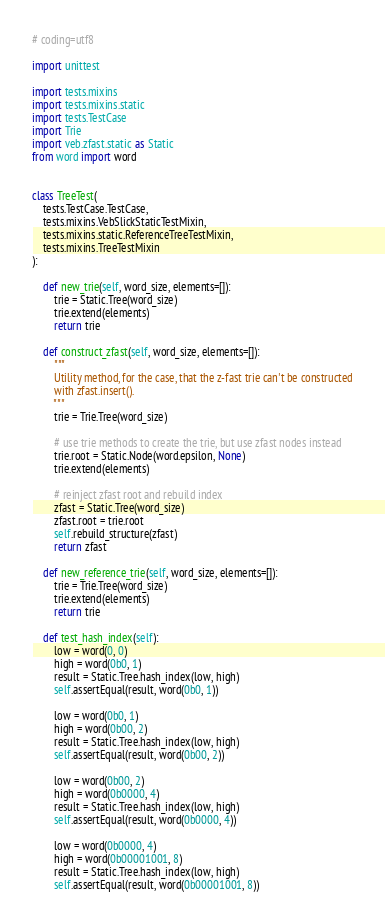<code> <loc_0><loc_0><loc_500><loc_500><_Python_># coding=utf8

import unittest

import tests.mixins
import tests.mixins.static
import tests.TestCase
import Trie
import veb.zfast.static as Static
from word import word


class TreeTest(
    tests.TestCase.TestCase,
    tests.mixins.VebSlickStaticTestMixin,
    tests.mixins.static.ReferenceTreeTestMixin,
    tests.mixins.TreeTestMixin
):

    def new_trie(self, word_size, elements=[]):
        trie = Static.Tree(word_size)
        trie.extend(elements)
        return trie

    def construct_zfast(self, word_size, elements=[]):
        """
        Utility method, for the case, that the z-fast trie can't be constructed
        with zfast.insert().
        """
        trie = Trie.Tree(word_size)

        # use trie methods to create the trie, but use zfast nodes instead
        trie.root = Static.Node(word.epsilon, None)
        trie.extend(elements)

        # reinject zfast root and rebuild index
        zfast = Static.Tree(word_size)
        zfast.root = trie.root
        self.rebuild_structure(zfast)
        return zfast

    def new_reference_trie(self, word_size, elements=[]):
        trie = Trie.Tree(word_size)
        trie.extend(elements)
        return trie

    def test_hash_index(self):
        low = word(0, 0)
        high = word(0b0, 1)
        result = Static.Tree.hash_index(low, high)
        self.assertEqual(result, word(0b0, 1))

        low = word(0b0, 1)
        high = word(0b00, 2)
        result = Static.Tree.hash_index(low, high)
        self.assertEqual(result, word(0b00, 2))

        low = word(0b00, 2)
        high = word(0b0000, 4)
        result = Static.Tree.hash_index(low, high)
        self.assertEqual(result, word(0b0000, 4))

        low = word(0b0000, 4)
        high = word(0b00001001, 8)
        result = Static.Tree.hash_index(low, high)
        self.assertEqual(result, word(0b00001001, 8))
</code> 